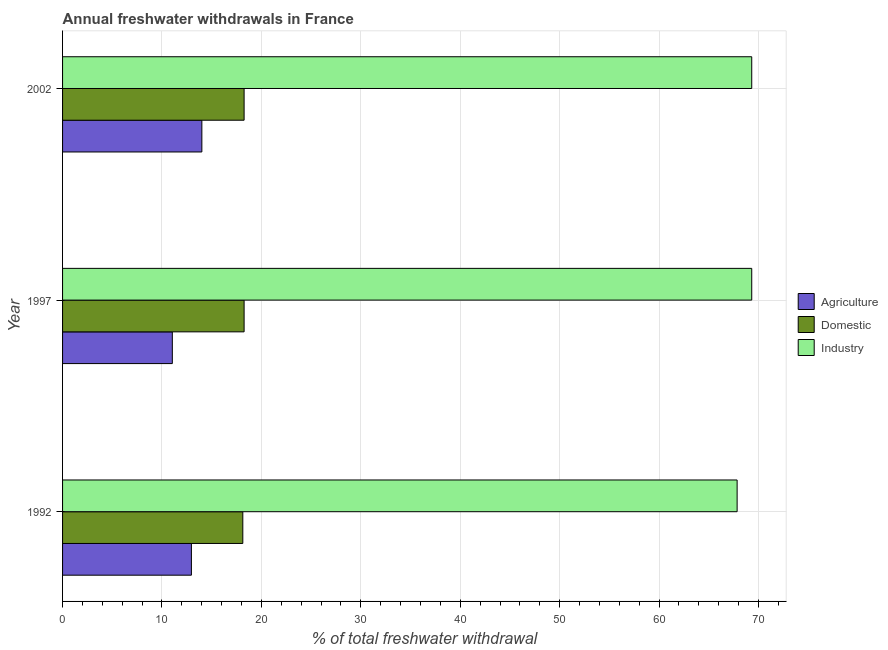How many groups of bars are there?
Your answer should be compact. 3. Are the number of bars per tick equal to the number of legend labels?
Make the answer very short. Yes. How many bars are there on the 1st tick from the top?
Offer a very short reply. 3. What is the label of the 1st group of bars from the top?
Make the answer very short. 2002. What is the percentage of freshwater withdrawal for domestic purposes in 1997?
Make the answer very short. 18.26. Across all years, what is the maximum percentage of freshwater withdrawal for domestic purposes?
Provide a short and direct response. 18.26. Across all years, what is the minimum percentage of freshwater withdrawal for agriculture?
Provide a short and direct response. 11.04. In which year was the percentage of freshwater withdrawal for domestic purposes minimum?
Make the answer very short. 1992. What is the total percentage of freshwater withdrawal for industry in the graph?
Ensure brevity in your answer.  206.49. What is the difference between the percentage of freshwater withdrawal for domestic purposes in 1997 and that in 2002?
Offer a terse response. 0. What is the difference between the percentage of freshwater withdrawal for domestic purposes in 1992 and the percentage of freshwater withdrawal for agriculture in 1997?
Keep it short and to the point. 7.09. What is the average percentage of freshwater withdrawal for agriculture per year?
Your answer should be compact. 12.67. In the year 2002, what is the difference between the percentage of freshwater withdrawal for industry and percentage of freshwater withdrawal for agriculture?
Make the answer very short. 55.31. What is the ratio of the percentage of freshwater withdrawal for agriculture in 1992 to that in 2002?
Provide a succinct answer. 0.93. Is the percentage of freshwater withdrawal for agriculture in 1997 less than that in 2002?
Provide a short and direct response. Yes. What is the difference between the highest and the second highest percentage of freshwater withdrawal for industry?
Provide a short and direct response. 0. What is the difference between the highest and the lowest percentage of freshwater withdrawal for agriculture?
Your answer should be very brief. 2.97. In how many years, is the percentage of freshwater withdrawal for domestic purposes greater than the average percentage of freshwater withdrawal for domestic purposes taken over all years?
Your response must be concise. 2. Is the sum of the percentage of freshwater withdrawal for agriculture in 1997 and 2002 greater than the maximum percentage of freshwater withdrawal for industry across all years?
Provide a succinct answer. No. What does the 2nd bar from the top in 1997 represents?
Your response must be concise. Domestic. What does the 3rd bar from the bottom in 1997 represents?
Provide a succinct answer. Industry. Is it the case that in every year, the sum of the percentage of freshwater withdrawal for agriculture and percentage of freshwater withdrawal for domestic purposes is greater than the percentage of freshwater withdrawal for industry?
Your answer should be compact. No. How many bars are there?
Provide a succinct answer. 9. What is the difference between two consecutive major ticks on the X-axis?
Give a very brief answer. 10. Are the values on the major ticks of X-axis written in scientific E-notation?
Provide a succinct answer. No. Does the graph contain any zero values?
Your answer should be compact. No. How are the legend labels stacked?
Keep it short and to the point. Vertical. What is the title of the graph?
Make the answer very short. Annual freshwater withdrawals in France. What is the label or title of the X-axis?
Provide a short and direct response. % of total freshwater withdrawal. What is the label or title of the Y-axis?
Offer a very short reply. Year. What is the % of total freshwater withdrawal of Agriculture in 1992?
Provide a succinct answer. 12.96. What is the % of total freshwater withdrawal in Domestic in 1992?
Your answer should be very brief. 18.13. What is the % of total freshwater withdrawal in Industry in 1992?
Your response must be concise. 67.85. What is the % of total freshwater withdrawal in Agriculture in 1997?
Offer a very short reply. 11.04. What is the % of total freshwater withdrawal in Domestic in 1997?
Give a very brief answer. 18.26. What is the % of total freshwater withdrawal of Industry in 1997?
Provide a short and direct response. 69.32. What is the % of total freshwater withdrawal in Agriculture in 2002?
Your answer should be very brief. 14.01. What is the % of total freshwater withdrawal of Domestic in 2002?
Offer a terse response. 18.26. What is the % of total freshwater withdrawal of Industry in 2002?
Ensure brevity in your answer.  69.32. Across all years, what is the maximum % of total freshwater withdrawal in Agriculture?
Your answer should be very brief. 14.01. Across all years, what is the maximum % of total freshwater withdrawal in Domestic?
Offer a very short reply. 18.26. Across all years, what is the maximum % of total freshwater withdrawal in Industry?
Give a very brief answer. 69.32. Across all years, what is the minimum % of total freshwater withdrawal of Agriculture?
Your response must be concise. 11.04. Across all years, what is the minimum % of total freshwater withdrawal of Domestic?
Your answer should be compact. 18.13. Across all years, what is the minimum % of total freshwater withdrawal in Industry?
Your response must be concise. 67.85. What is the total % of total freshwater withdrawal of Agriculture in the graph?
Your answer should be very brief. 38.01. What is the total % of total freshwater withdrawal in Domestic in the graph?
Your answer should be very brief. 54.65. What is the total % of total freshwater withdrawal of Industry in the graph?
Your answer should be very brief. 206.49. What is the difference between the % of total freshwater withdrawal in Agriculture in 1992 and that in 1997?
Keep it short and to the point. 1.92. What is the difference between the % of total freshwater withdrawal in Domestic in 1992 and that in 1997?
Your answer should be very brief. -0.13. What is the difference between the % of total freshwater withdrawal in Industry in 1992 and that in 1997?
Your answer should be compact. -1.47. What is the difference between the % of total freshwater withdrawal of Agriculture in 1992 and that in 2002?
Offer a terse response. -1.05. What is the difference between the % of total freshwater withdrawal of Domestic in 1992 and that in 2002?
Offer a terse response. -0.13. What is the difference between the % of total freshwater withdrawal in Industry in 1992 and that in 2002?
Give a very brief answer. -1.47. What is the difference between the % of total freshwater withdrawal of Agriculture in 1997 and that in 2002?
Your answer should be compact. -2.97. What is the difference between the % of total freshwater withdrawal in Domestic in 1997 and that in 2002?
Your response must be concise. 0. What is the difference between the % of total freshwater withdrawal in Industry in 1997 and that in 2002?
Provide a short and direct response. 0. What is the difference between the % of total freshwater withdrawal of Agriculture in 1992 and the % of total freshwater withdrawal of Domestic in 1997?
Ensure brevity in your answer.  -5.3. What is the difference between the % of total freshwater withdrawal of Agriculture in 1992 and the % of total freshwater withdrawal of Industry in 1997?
Offer a very short reply. -56.36. What is the difference between the % of total freshwater withdrawal in Domestic in 1992 and the % of total freshwater withdrawal in Industry in 1997?
Offer a terse response. -51.19. What is the difference between the % of total freshwater withdrawal of Agriculture in 1992 and the % of total freshwater withdrawal of Industry in 2002?
Offer a very short reply. -56.36. What is the difference between the % of total freshwater withdrawal of Domestic in 1992 and the % of total freshwater withdrawal of Industry in 2002?
Offer a very short reply. -51.19. What is the difference between the % of total freshwater withdrawal of Agriculture in 1997 and the % of total freshwater withdrawal of Domestic in 2002?
Offer a very short reply. -7.22. What is the difference between the % of total freshwater withdrawal in Agriculture in 1997 and the % of total freshwater withdrawal in Industry in 2002?
Your response must be concise. -58.28. What is the difference between the % of total freshwater withdrawal in Domestic in 1997 and the % of total freshwater withdrawal in Industry in 2002?
Offer a terse response. -51.06. What is the average % of total freshwater withdrawal in Agriculture per year?
Provide a short and direct response. 12.67. What is the average % of total freshwater withdrawal of Domestic per year?
Provide a short and direct response. 18.22. What is the average % of total freshwater withdrawal in Industry per year?
Provide a short and direct response. 68.83. In the year 1992, what is the difference between the % of total freshwater withdrawal in Agriculture and % of total freshwater withdrawal in Domestic?
Ensure brevity in your answer.  -5.17. In the year 1992, what is the difference between the % of total freshwater withdrawal in Agriculture and % of total freshwater withdrawal in Industry?
Make the answer very short. -54.89. In the year 1992, what is the difference between the % of total freshwater withdrawal of Domestic and % of total freshwater withdrawal of Industry?
Provide a short and direct response. -49.72. In the year 1997, what is the difference between the % of total freshwater withdrawal of Agriculture and % of total freshwater withdrawal of Domestic?
Your answer should be compact. -7.22. In the year 1997, what is the difference between the % of total freshwater withdrawal of Agriculture and % of total freshwater withdrawal of Industry?
Give a very brief answer. -58.28. In the year 1997, what is the difference between the % of total freshwater withdrawal of Domestic and % of total freshwater withdrawal of Industry?
Your answer should be very brief. -51.06. In the year 2002, what is the difference between the % of total freshwater withdrawal of Agriculture and % of total freshwater withdrawal of Domestic?
Your answer should be very brief. -4.25. In the year 2002, what is the difference between the % of total freshwater withdrawal of Agriculture and % of total freshwater withdrawal of Industry?
Ensure brevity in your answer.  -55.31. In the year 2002, what is the difference between the % of total freshwater withdrawal of Domestic and % of total freshwater withdrawal of Industry?
Keep it short and to the point. -51.06. What is the ratio of the % of total freshwater withdrawal of Agriculture in 1992 to that in 1997?
Keep it short and to the point. 1.17. What is the ratio of the % of total freshwater withdrawal of Domestic in 1992 to that in 1997?
Your answer should be compact. 0.99. What is the ratio of the % of total freshwater withdrawal in Industry in 1992 to that in 1997?
Your response must be concise. 0.98. What is the ratio of the % of total freshwater withdrawal in Agriculture in 1992 to that in 2002?
Provide a succinct answer. 0.93. What is the ratio of the % of total freshwater withdrawal of Industry in 1992 to that in 2002?
Your answer should be compact. 0.98. What is the ratio of the % of total freshwater withdrawal in Agriculture in 1997 to that in 2002?
Provide a succinct answer. 0.79. What is the ratio of the % of total freshwater withdrawal of Domestic in 1997 to that in 2002?
Keep it short and to the point. 1. What is the difference between the highest and the second highest % of total freshwater withdrawal in Agriculture?
Offer a very short reply. 1.05. What is the difference between the highest and the second highest % of total freshwater withdrawal in Domestic?
Your answer should be very brief. 0. What is the difference between the highest and the lowest % of total freshwater withdrawal of Agriculture?
Your answer should be compact. 2.97. What is the difference between the highest and the lowest % of total freshwater withdrawal in Domestic?
Offer a terse response. 0.13. What is the difference between the highest and the lowest % of total freshwater withdrawal in Industry?
Offer a very short reply. 1.47. 